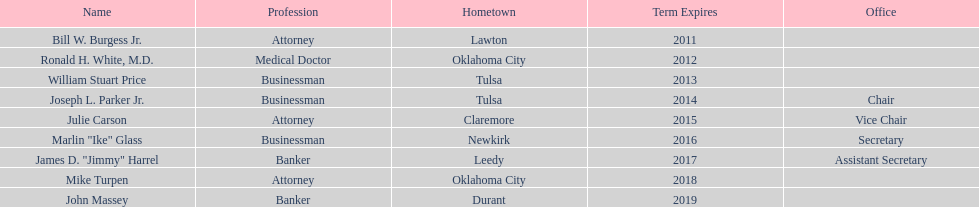Which state regent comes from the same hometown as ronald h. white, m.d.? Mike Turpen. Parse the table in full. {'header': ['Name', 'Profession', 'Hometown', 'Term Expires', 'Office'], 'rows': [['Bill W. Burgess Jr.', 'Attorney', 'Lawton', '2011', ''], ['Ronald H. White, M.D.', 'Medical Doctor', 'Oklahoma City', '2012', ''], ['William Stuart Price', 'Businessman', 'Tulsa', '2013', ''], ['Joseph L. Parker Jr.', 'Businessman', 'Tulsa', '2014', 'Chair'], ['Julie Carson', 'Attorney', 'Claremore', '2015', 'Vice Chair'], ['Marlin "Ike" Glass', 'Businessman', 'Newkirk', '2016', 'Secretary'], ['James D. "Jimmy" Harrel', 'Banker', 'Leedy', '2017', 'Assistant Secretary'], ['Mike Turpen', 'Attorney', 'Oklahoma City', '2018', ''], ['John Massey', 'Banker', 'Durant', '2019', '']]} 